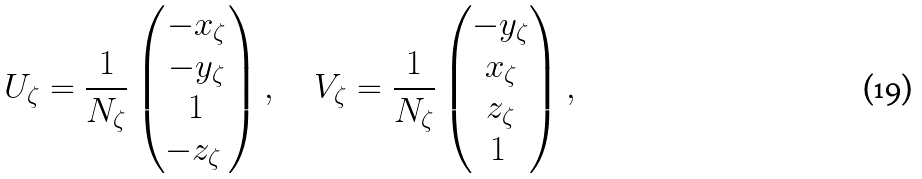<formula> <loc_0><loc_0><loc_500><loc_500>U _ { \zeta } = \frac { 1 } { N _ { \zeta } } \begin{pmatrix} - x _ { \zeta } \\ - y _ { \zeta } \\ 1 \\ - z _ { \zeta } \ \end{pmatrix} , \quad V _ { \zeta } = \frac { 1 } { N _ { \zeta } } \begin{pmatrix} - y _ { \zeta } \\ x _ { \zeta } \\ z _ { \zeta } \\ 1 \ \end{pmatrix} ,</formula> 